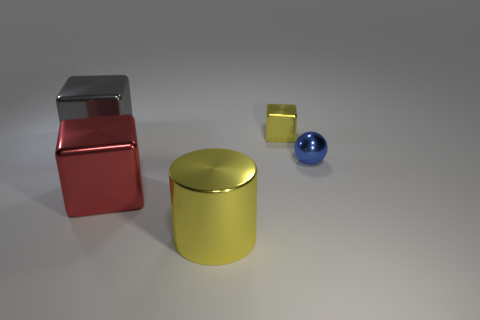What is the shape of the metallic thing that is the same color as the cylinder?
Offer a very short reply. Cube. Is the color of the shiny block on the right side of the red block the same as the cube in front of the sphere?
Keep it short and to the point. No. The big metal object that is behind the big cylinder and in front of the gray thing has what shape?
Give a very brief answer. Cube. What color is the shiny cube that is the same size as the blue sphere?
Ensure brevity in your answer.  Yellow. Are there any tiny metal balls of the same color as the tiny cube?
Your answer should be very brief. No. There is a thing left of the red block; does it have the same size as the yellow thing that is in front of the yellow cube?
Make the answer very short. Yes. There is a thing that is behind the large red cube and in front of the large gray shiny block; what is it made of?
Ensure brevity in your answer.  Metal. What is the size of the shiny thing that is the same color as the small cube?
Offer a very short reply. Large. How many other things are the same size as the red metal thing?
Provide a succinct answer. 2. What is the small object that is in front of the gray metallic cube made of?
Keep it short and to the point. Metal. 